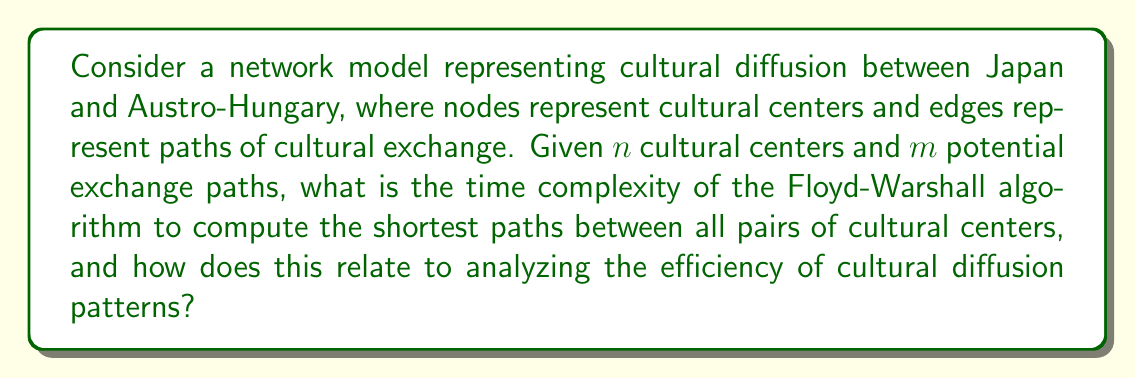What is the answer to this math problem? To analyze this problem, we need to consider the Floyd-Warshall algorithm, which is commonly used in network analysis to find the shortest paths between all pairs of nodes in a weighted graph.

1. Algorithm Overview:
   The Floyd-Warshall algorithm works by iteratively improving the estimate of the shortest path between each pair of nodes. It does this by considering whether going through an intermediate node results in a shorter path.

2. Time Complexity Analysis:
   - The algorithm uses three nested loops, each iterating over all nodes.
   - For $n$ cultural centers, each loop runs $n$ times.
   - This results in a time complexity of $O(n^3)$.

3. Space Complexity:
   - The algorithm typically uses an $n \times n$ matrix to store the distances between all pairs of nodes.
   - This results in a space complexity of $O(n^2)$.

4. Relation to Cultural Diffusion:
   - In the context of cultural diffusion between Japan and Austro-Hungary, this algorithm allows us to determine the most efficient paths for cultural exchange between any two centers.
   - The $O(n^3)$ time complexity indicates that the computational effort grows cubically with the number of cultural centers, which could be a limiting factor for very large networks.

5. Comparison to Other Algorithms:
   - For sparse graphs (where $m \ll n^2$), algorithms like Johnson's might be more efficient, with a time complexity of $O(n^2 \log n + nm)$.
   - However, Floyd-Warshall is simpler to implement and works well for dense graphs.

6. Historical Context:
   - While the algorithm itself is modern, it can be applied to historical data to analyze patterns of cultural diffusion that occurred between Japan and Austro-Hungary during their periods of interaction.

The $O(n^3)$ time complexity means that doubling the number of cultural centers would increase the computation time by a factor of 8, which is important to consider when modeling large-scale cultural networks.
Answer: The time complexity of the Floyd-Warshall algorithm for computing shortest paths between all pairs of cultural centers in a network with $n$ nodes is $O(n^3)$. This cubic growth rate indicates that the algorithm's efficiency decreases rapidly as the number of cultural centers increases, which is crucial to consider when analyzing large-scale cultural diffusion patterns between Japan and Austro-Hungary. 